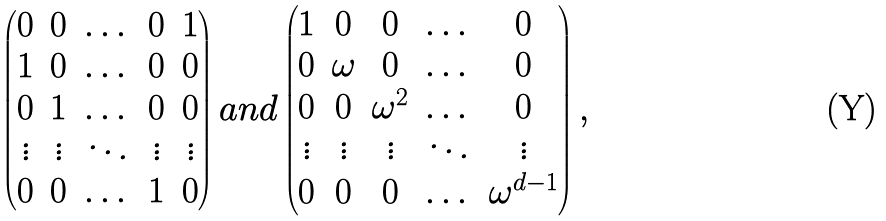Convert formula to latex. <formula><loc_0><loc_0><loc_500><loc_500>\begin{pmatrix} 0 & 0 & \dots & 0 & 1 \\ 1 & 0 & \dots & 0 & 0 \\ 0 & 1 & \dots & 0 & 0 \\ \vdots & \vdots & \ddots & \vdots & \vdots \\ 0 & 0 & \dots & 1 & 0 \end{pmatrix} a n d \begin{pmatrix} 1 & 0 & 0 & \dots & 0 \\ 0 & \omega & 0 & \dots & 0 \\ 0 & 0 & \omega ^ { 2 } & \dots & 0 \\ \vdots & \vdots & \vdots & \ddots & \vdots \\ 0 & 0 & 0 & \dots & \omega ^ { d - 1 } \end{pmatrix} ,</formula> 